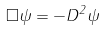Convert formula to latex. <formula><loc_0><loc_0><loc_500><loc_500>\square \psi = - D ^ { 2 } \psi</formula> 